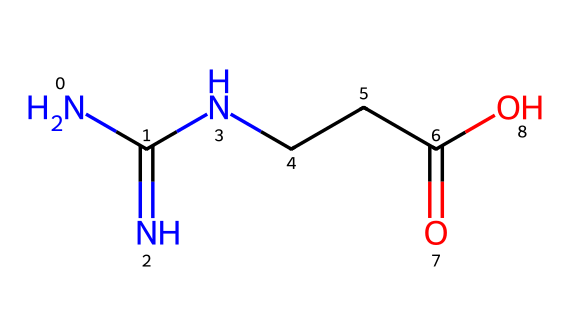What is the main functional group in creatine? The structural formula shows a carboxylic acid group (−COOH), which is identified by the carbon atom double-bonded to an oxygen and single-bonded to a hydroxyl group.
Answer: carboxylic acid How many nitrogen atoms are in the creatine molecule? By examining the SMILES representation, there are three nitrogen atoms indicated by "N" in the formula, which can be counted directly.
Answer: three What is the total number of carbon atoms in creatine? The SMILES notation contains four "C" symbols, which represent the carbon atoms in the structure, providing a total count when summed.
Answer: four What type of biological molecule is creatine classified as? Creatine is classified as an amino acid derivative based on its carbon, nitrogen, and carboxylic acid components, indicating its role in biological systems.
Answer: amino acid derivative What characteristic feature of creatine supports its role in energy metabolism? Creatine contains a high-energy phosphate group as part of its structure, which is critical for ATP production and energy transfer in cells.
Answer: high-energy phosphate group How many oxygen atoms are present in creatine? The SMILES shows two oxygen atoms represented by "O," which can be counted directly from the structure.
Answer: two 